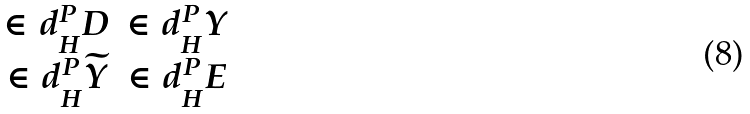Convert formula to latex. <formula><loc_0><loc_0><loc_500><loc_500>\begin{matrix} \in d _ { H } ^ { P } D & \in d _ { H } ^ { P } Y \\ \in d _ { H } ^ { P } \widetilde { Y } & \in d _ { H } ^ { P } E \end{matrix}</formula> 